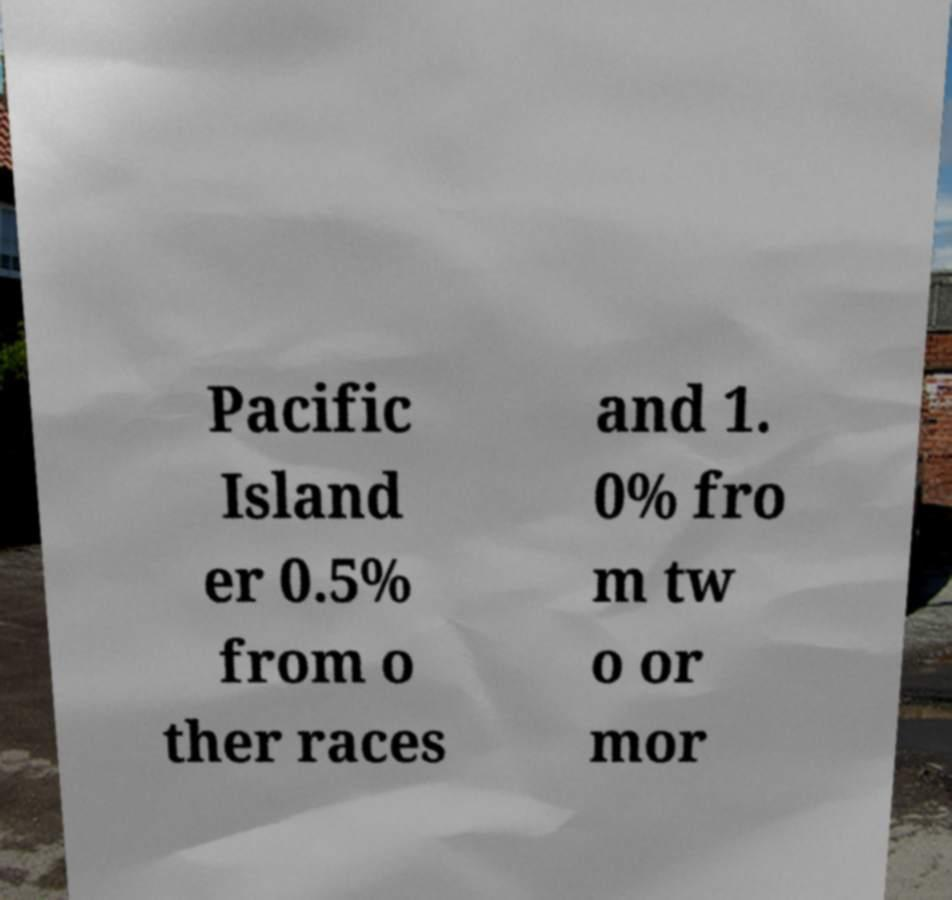Can you read and provide the text displayed in the image?This photo seems to have some interesting text. Can you extract and type it out for me? Pacific Island er 0.5% from o ther races and 1. 0% fro m tw o or mor 